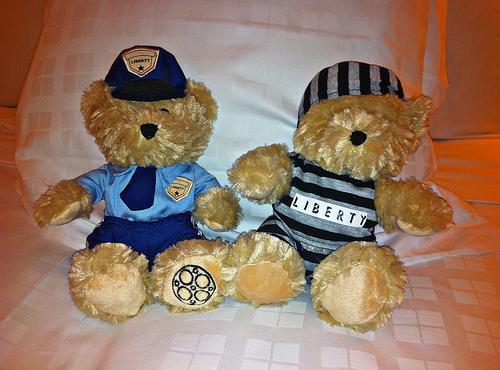How many teddy bears are there?
Give a very brief answer. 2. 